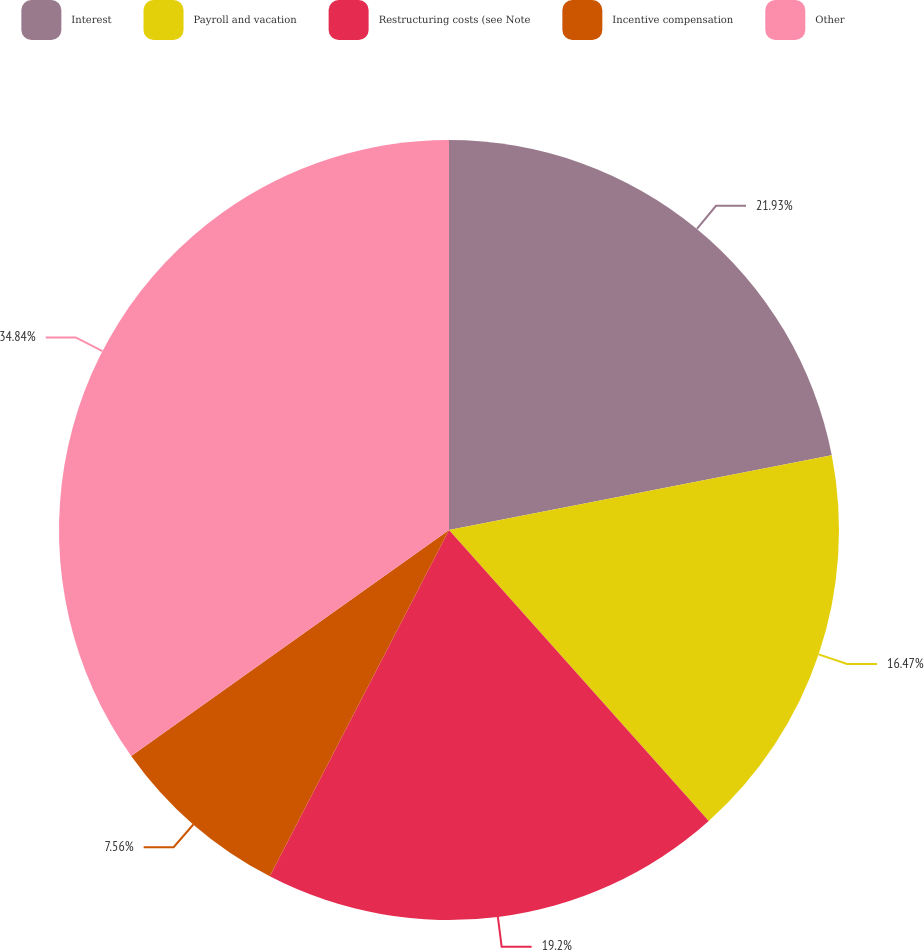Convert chart to OTSL. <chart><loc_0><loc_0><loc_500><loc_500><pie_chart><fcel>Interest<fcel>Payroll and vacation<fcel>Restructuring costs (see Note<fcel>Incentive compensation<fcel>Other<nl><fcel>21.93%<fcel>16.47%<fcel>19.2%<fcel>7.56%<fcel>34.84%<nl></chart> 